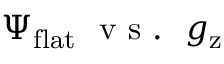Convert formula to latex. <formula><loc_0><loc_0><loc_500><loc_500>\Psi _ { f l a t } v s . g _ { z }</formula> 